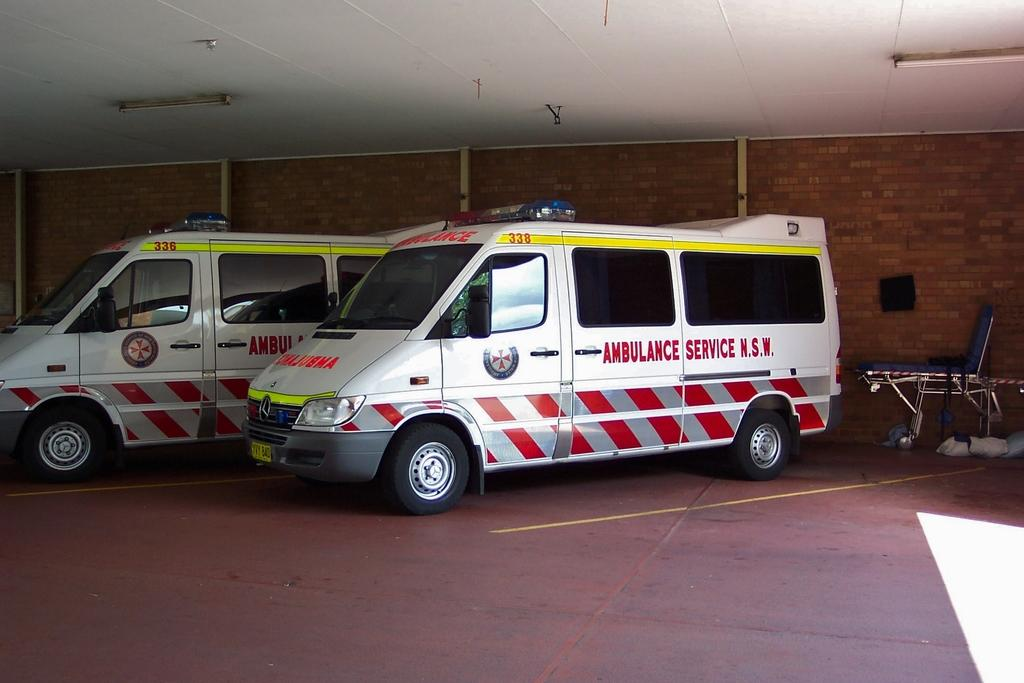<image>
Summarize the visual content of the image. The Ambulance service is from New South Wales. 